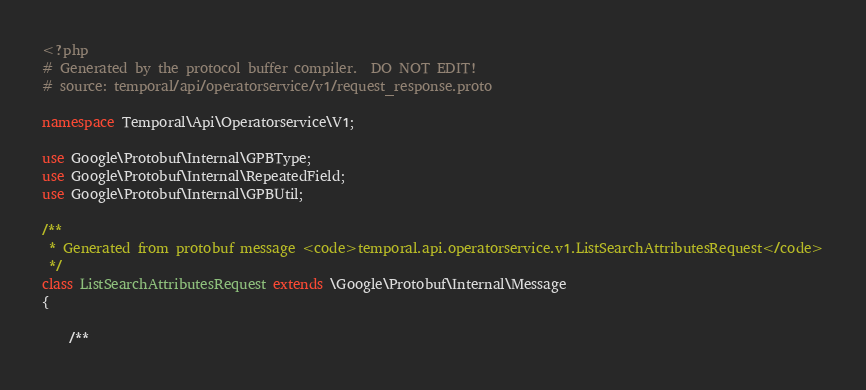Convert code to text. <code><loc_0><loc_0><loc_500><loc_500><_PHP_><?php
# Generated by the protocol buffer compiler.  DO NOT EDIT!
# source: temporal/api/operatorservice/v1/request_response.proto

namespace Temporal\Api\Operatorservice\V1;

use Google\Protobuf\Internal\GPBType;
use Google\Protobuf\Internal\RepeatedField;
use Google\Protobuf\Internal\GPBUtil;

/**
 * Generated from protobuf message <code>temporal.api.operatorservice.v1.ListSearchAttributesRequest</code>
 */
class ListSearchAttributesRequest extends \Google\Protobuf\Internal\Message
{

    /**</code> 